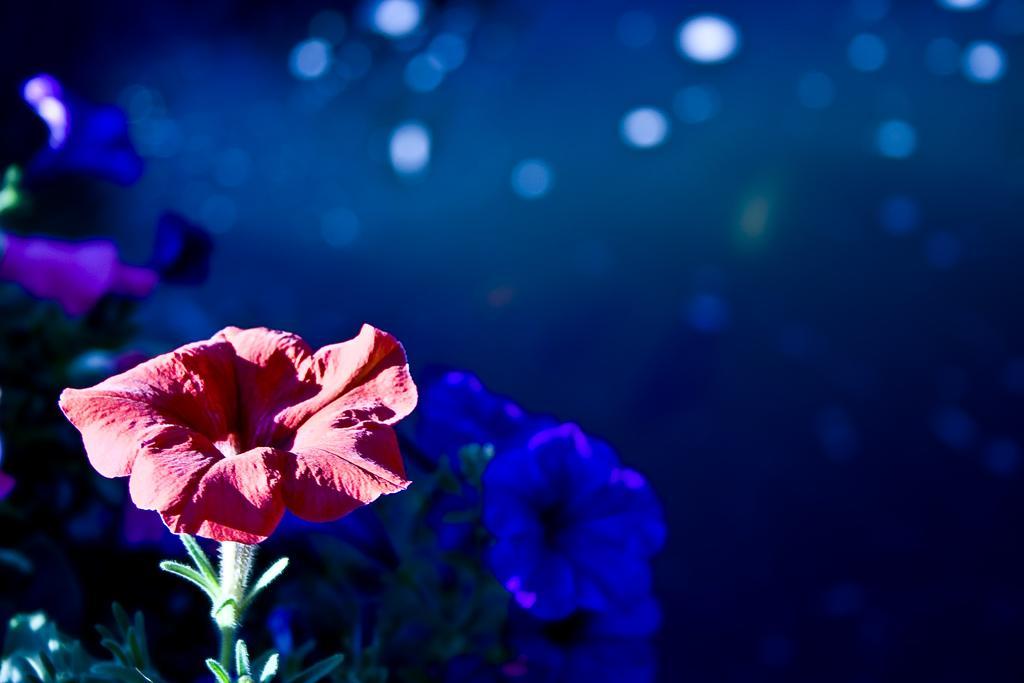How would you summarize this image in a sentence or two? We can see flowers and stem. Background it is blue color. 